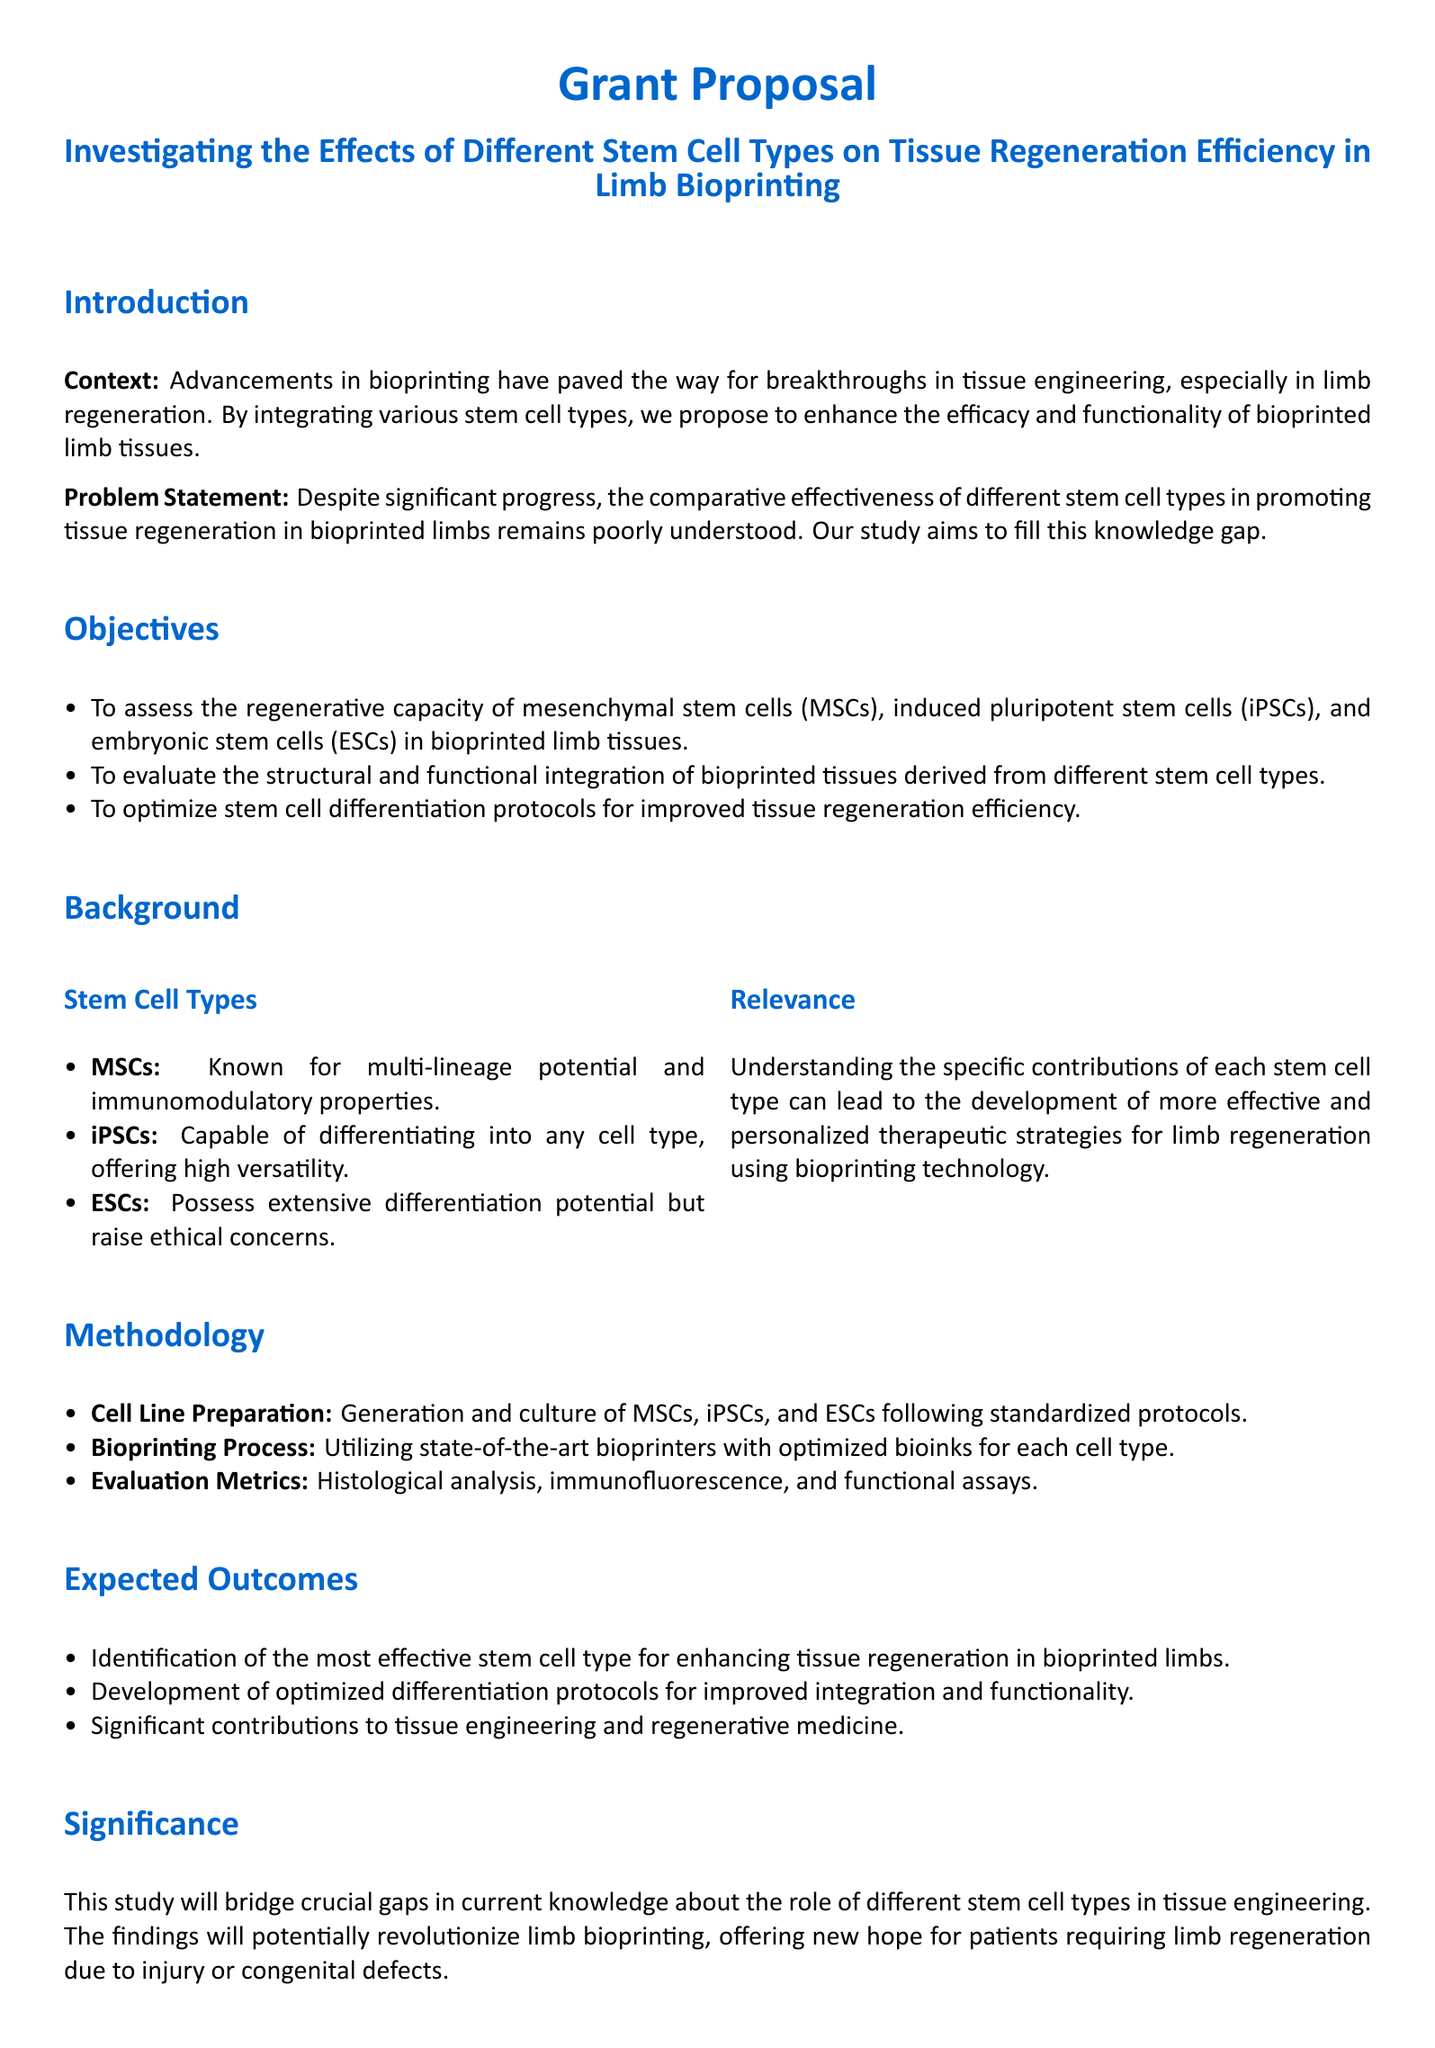What is the title of the proposal? The title is located at the beginning of the document and states the focus of the study.
Answer: Investigating the Effects of Different Stem Cell Types on Tissue Regeneration Efficiency in Limb Bioprinting How many types of stem cells are mentioned? The document describes three specific types of stem cells relevant to the study.
Answer: Three What is the budget estimate for personnel? The budget section lists the costs associated with various aspects, including personnel.
Answer: $100,000 What is the primary objective of the study? The objectives section outlines the main aims of the research.
Answer: To assess the regenerative capacity of mesenchymal stem cells, induced pluripotent stem cells, and embryonic stem cells in bioprinted limb tissues What evaluation methods will be used in the methodology? The methodology section lists different metrics for analysis.
Answer: Histological analysis, immunofluorescence, and functional assays Why is this study significant? The significance section explains the broader impact on tissue engineering and limb regeneration.
Answer: It will bridge crucial gaps in current knowledge about the role of different stem cell types in tissue engineering Which stem cell type raises ethical concerns? The background section details the unique aspects of each stem cell type, including ethical considerations.
Answer: Embryonic stem cells What is the expected outcome related to stem cell types? The expected outcomes specify what the researchers aim to discover regarding stem cells and regeneration.
Answer: Identification of the most effective stem cell type for enhancing tissue regeneration in bioprinted limbs 